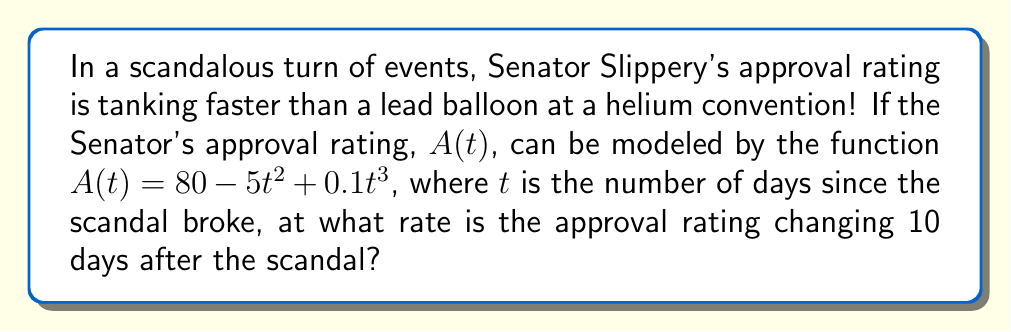Can you answer this question? To find the rate of change of the Senator's approval rating 10 days after the scandal, we need to calculate the derivative of $A(t)$ and evaluate it at $t = 10$. Let's break it down step-by-step:

1) The given function is $A(t) = 80 - 5t^2 + 0.1t^3$

2) To find the rate of change, we need to find $A'(t)$:
   $$\frac{d}{dt}(80) = 0$$
   $$\frac{d}{dt}(-5t^2) = -10t$$
   $$\frac{d}{dt}(0.1t^3) = 0.3t^2$$

3) Combining these results:
   $$A'(t) = -10t + 0.3t^2$$

4) Now, we evaluate $A'(t)$ at $t = 10$:
   $$A'(10) = -10(10) + 0.3(10)^2$$
   $$= -100 + 0.3(100)$$
   $$= -100 + 30$$
   $$= -70$$

The negative value indicates that the approval rating is decreasing.
Answer: The approval rating is changing at a rate of $-70$ percentage points per day, 10 days after the scandal broke. 